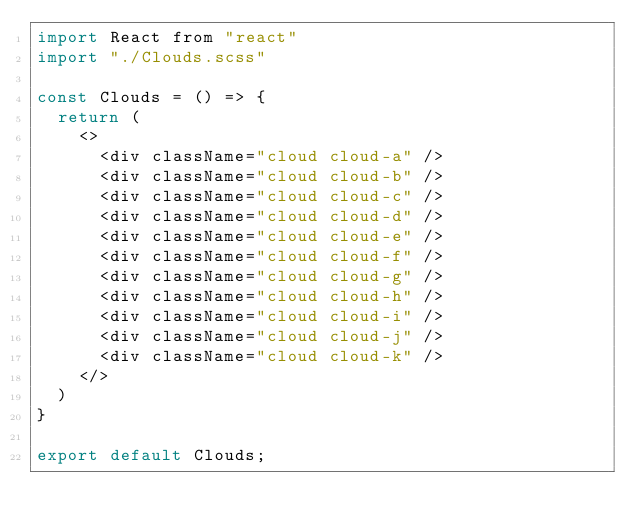<code> <loc_0><loc_0><loc_500><loc_500><_JavaScript_>import React from "react"
import "./Clouds.scss"

const Clouds = () => {
  return (
    <>
      <div className="cloud cloud-a" />
      <div className="cloud cloud-b" />
      <div className="cloud cloud-c" />
      <div className="cloud cloud-d" />
      <div className="cloud cloud-e" />
      <div className="cloud cloud-f" />
      <div className="cloud cloud-g" />
      <div className="cloud cloud-h" />
      <div className="cloud cloud-i" />
      <div className="cloud cloud-j" />
      <div className="cloud cloud-k" />
    </>
  )
}

export default Clouds;
</code> 